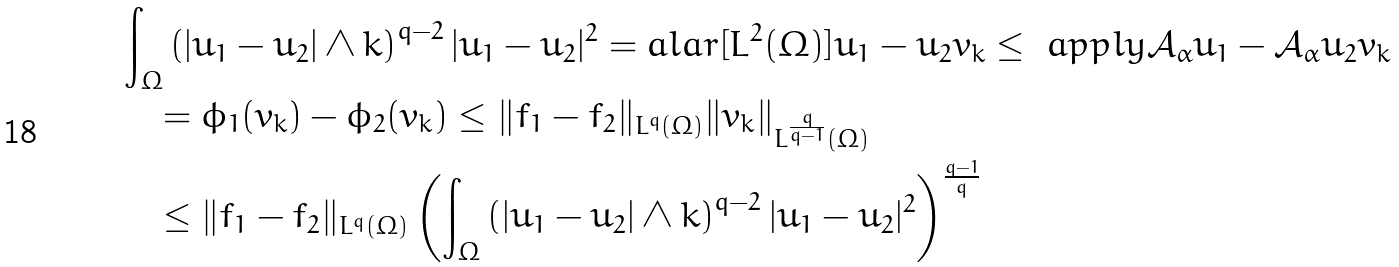Convert formula to latex. <formula><loc_0><loc_0><loc_500><loc_500>& \int _ { \Omega } \left ( | u _ { 1 } - u _ { 2 } | \wedge k \right ) ^ { q - 2 } | u _ { 1 } - u _ { 2 } | ^ { 2 } = a l a r [ L ^ { 2 } ( \Omega ) ] { u _ { 1 } - u _ { 2 } } { v _ { k } } \leq \ a p p l y { \mathcal { A } _ { \alpha } u _ { 1 } - \mathcal { A } _ { \alpha } u _ { 2 } } { v _ { k } } \\ & \quad = \phi _ { 1 } ( v _ { k } ) - \phi _ { 2 } ( v _ { k } ) \leq \| f _ { 1 } - f _ { 2 } \| _ { L ^ { q } ( \Omega ) } \| v _ { k } \| _ { L ^ { \frac { q } { q - 1 } } ( \Omega ) } \\ & \quad \leq \| f _ { 1 } - f _ { 2 } \| _ { L ^ { q } ( \Omega ) } \left ( \int _ { \Omega } \left ( | u _ { 1 } - u _ { 2 } | \wedge k \right ) ^ { q - 2 } | u _ { 1 } - u _ { 2 } | ^ { 2 } \right ) ^ { \frac { q - 1 } { q } }</formula> 